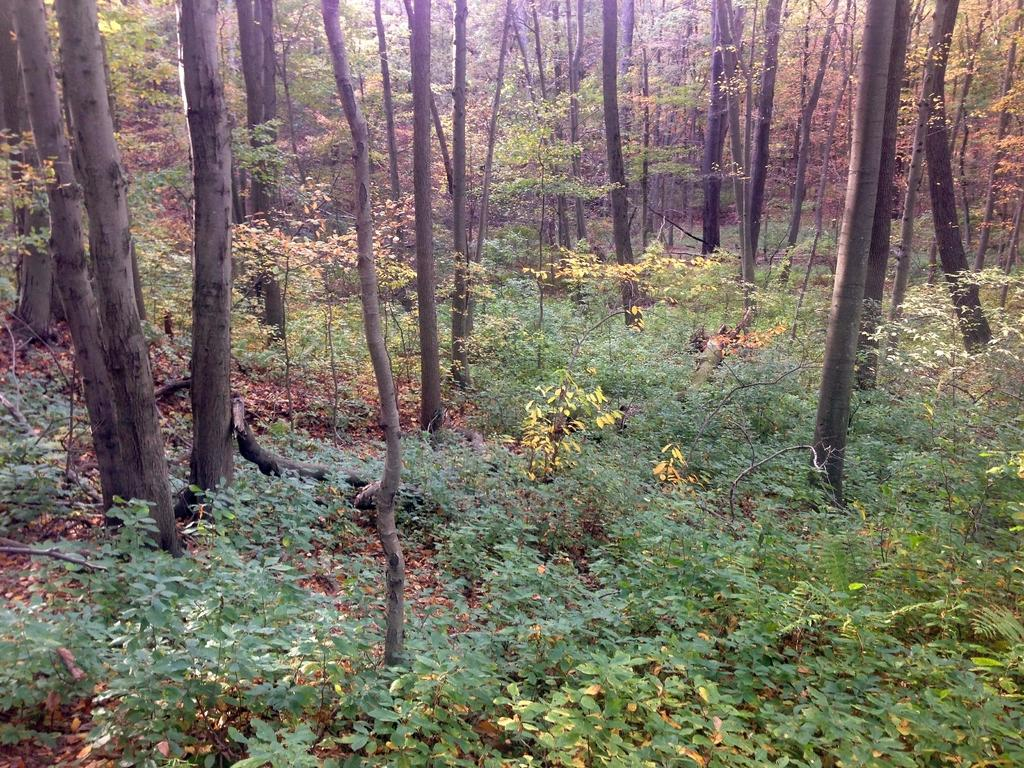What type of vegetation can be seen in the image? There are many trees, plants, and grass visible in the image. Can you describe the leaves in the image? Yes, leaves are visible at the bottom of the image. What time of day is depicted in the image? The time of day is not mentioned or depicted in the image. Can you see a carriage in the image? No, there is no carriage present in the image. 